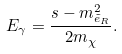Convert formula to latex. <formula><loc_0><loc_0><loc_500><loc_500>E _ { \gamma } = \frac { s - m ^ { 2 } _ { \tilde { e } _ { R } } } { 2 m _ { \chi } } .</formula> 